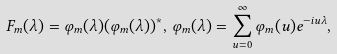<formula> <loc_0><loc_0><loc_500><loc_500>F _ { m } ( \lambda ) = \varphi _ { m } ( \lambda ) ( \varphi _ { m } ( \lambda ) ) ^ { * } , \, \varphi _ { m } ( \lambda ) = \sum _ { u = 0 } ^ { \infty } \varphi _ { m } ( u ) e ^ { - i u \lambda } ,</formula> 